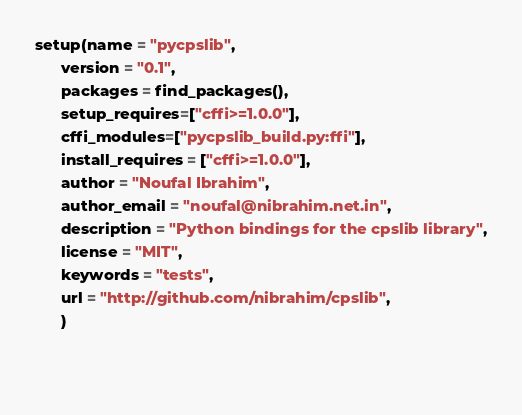Convert code to text. <code><loc_0><loc_0><loc_500><loc_500><_Python_>
setup(name = "pycpslib",
      version = "0.1",
      packages = find_packages(),
      setup_requires=["cffi>=1.0.0"],
      cffi_modules=["pycpslib_build.py:ffi"],
      install_requires = ["cffi>=1.0.0"],
      author = "Noufal Ibrahim",
      author_email = "noufal@nibrahim.net.in",
      description = "Python bindings for the cpslib library",
      license = "MIT",
      keywords = "tests",
      url = "http://github.com/nibrahim/cpslib",
      )

      
</code> 